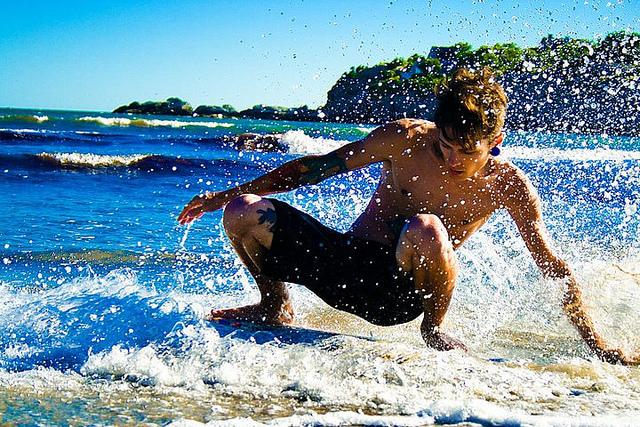Is the boy even in deep waters?
Answer briefly. No. Where is this?
Write a very short answer. Ocean. What is the man doing?
Quick response, please. Surfing. 